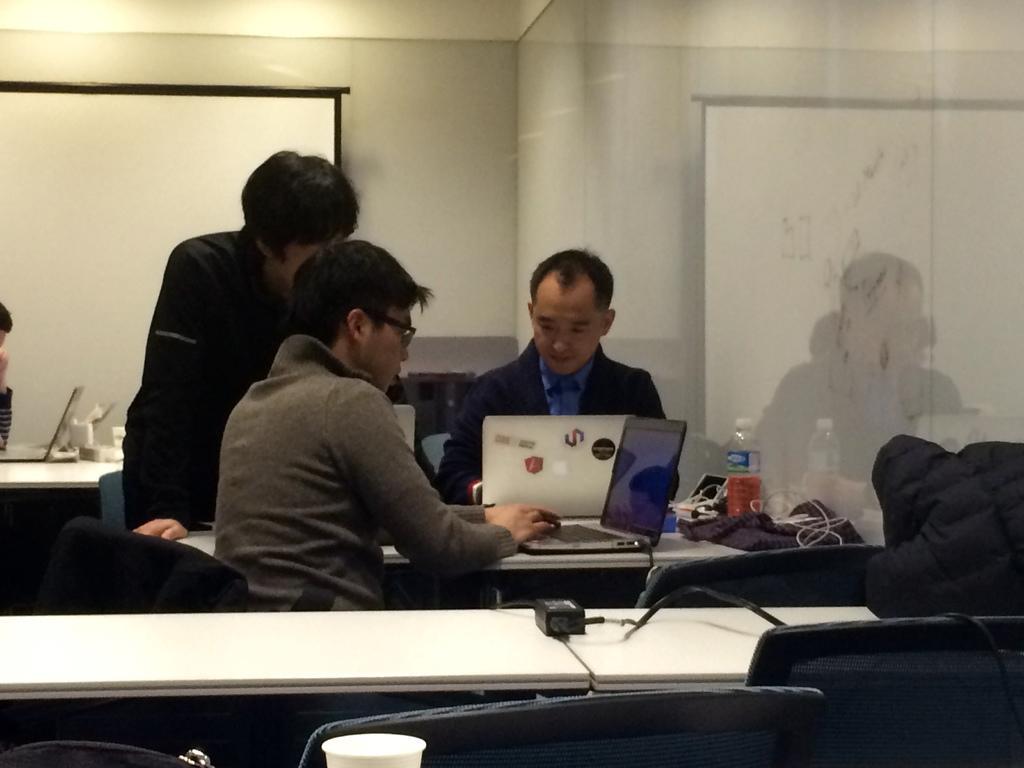Can you describe this image briefly? In this image there are three men who are looking at a laptop. The man to the right side is working with a laptop. In front there is a table and an adapter on it. At the background there is a wall and a screen attached to it. On the table there are glass,plastic bottle,clothes,wires. 